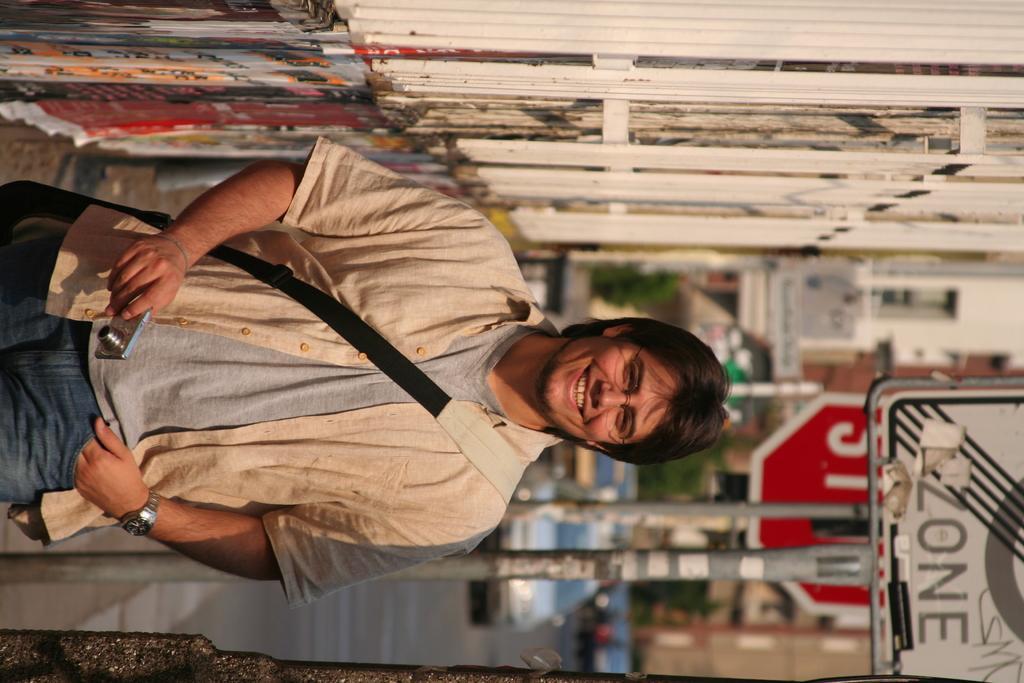Can you describe this image briefly? In this image there is a person standing, there is a person holding a camera, a person is wearing a bag, there is a pole truncated, there is a sign board, there are vehicles on the road, towards the right of the image there is a wall, towards the top of the image there is a wall. 